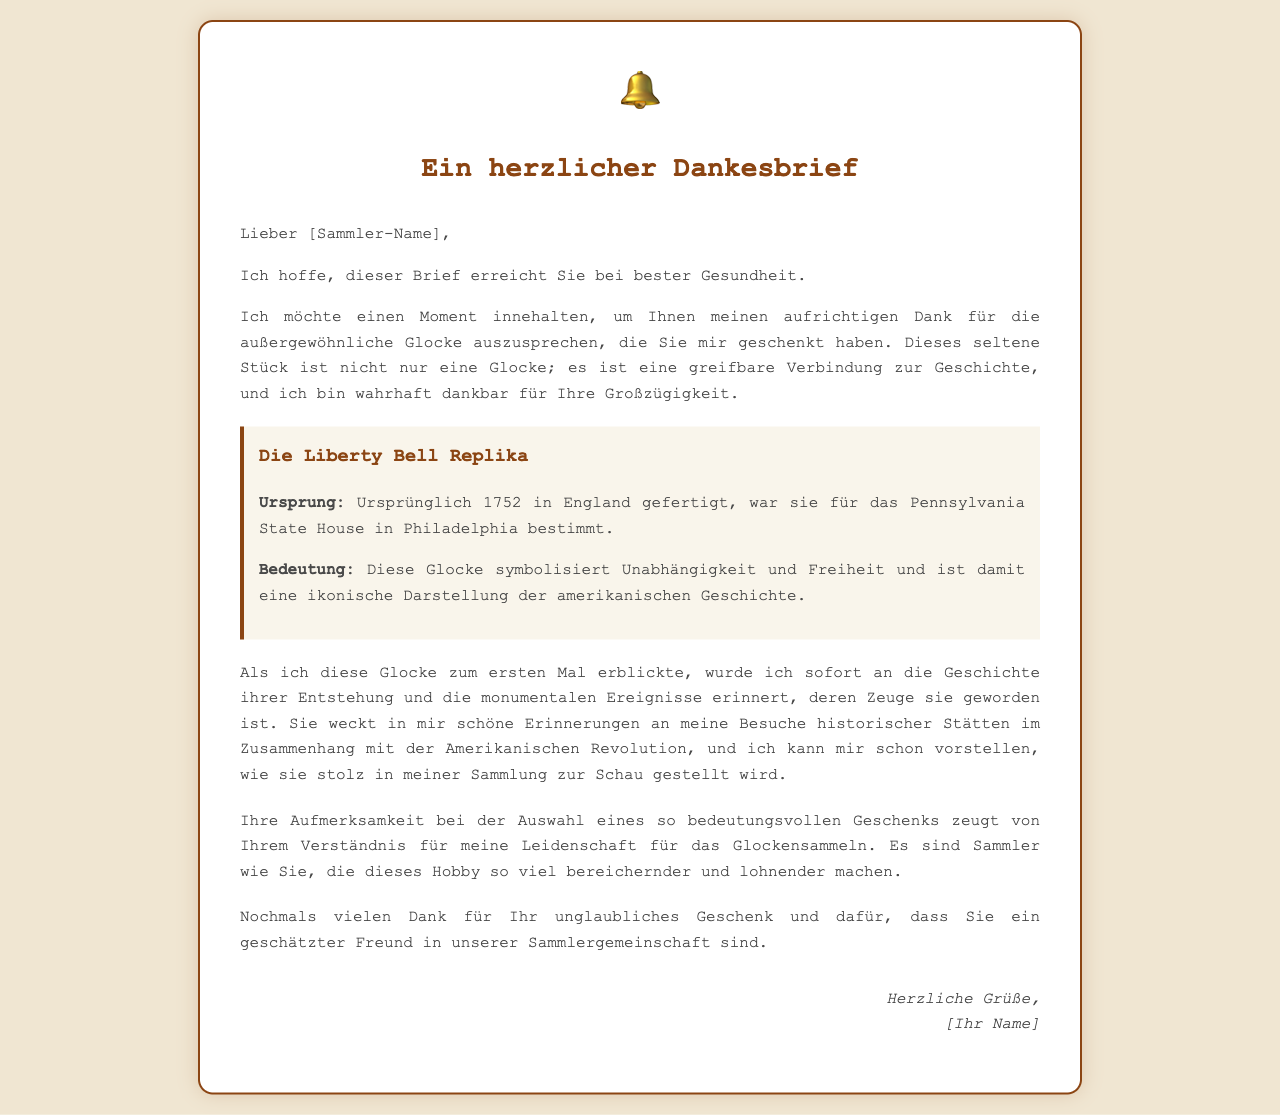Wer ist der Empfänger des Briefes? Der Empfänger des Briefes wird direkt im Text angesprochen, es ist ein Sammler mit dem Platzhalter [Sammler-Name].
Answer: [Sammler-Name] Was symbolisiert die Liberty Bell? Die Liberty Bell wird im Dokument als Symbol für Unabhängigkeit und Freiheit beschrieben.
Answer: Unabhängigkeit und Freiheit In welchem Jahr wurde die Liberty Bell originally gefertigt? Die Glocke wurde ursprünglich im Jahr 1752 gefertigt, laut der Beschreibung im Dokument.
Answer: 1752 Wo sollte die Liberty Bell ursprünglich platziert werden? Die Liberty Bell war ursprünglich für das Pennsylvania State House in Philadelphia bestimmt, das im Dokument erwähnt wird.
Answer: Pennsylvania State House Wie beschreibt der Autor die Beziehung zur Glocke? Die Glocke wird als greifbare Verbindung zur Geschichte bezeichnet, was die Bedeutung des Geschenks unterstreicht.
Answer: greifbare Verbindung zur Geschichte Was sagt der Autor über das Geschenktes von dem Sammler? Der Autor schätzt die Großzügigkeit des Sammlers und nennt es ein unglaubliches Geschenk.
Answer: unglaubliches Geschenk Wie wird die Bedeutung des Geschenks im Brief reflektiert? Der Autor reflektiert die Bedeutung des Geschenks durch die Verbindung zur amerikanischen Geschichte und persönlichen Erinnerungen.
Answer: Verbindung zur amerikanischen Geschichte Wie wird die Aufmerksamkeit des Sammlers gewürdigt? Die Wahl des bedeutungsvollen Geschenks wird als Zeichen des Verständnisses für die Leidenschaft des Autors angesehen.
Answer: Verständnis für meine Leidenschaft Was ist das Hauptthema des Briefes? Der Hauptinhalt des Briefes ist der Dank für ein Geschenk, das eine besondere Bedeutung hat.
Answer: Dank für ein Geschenk 